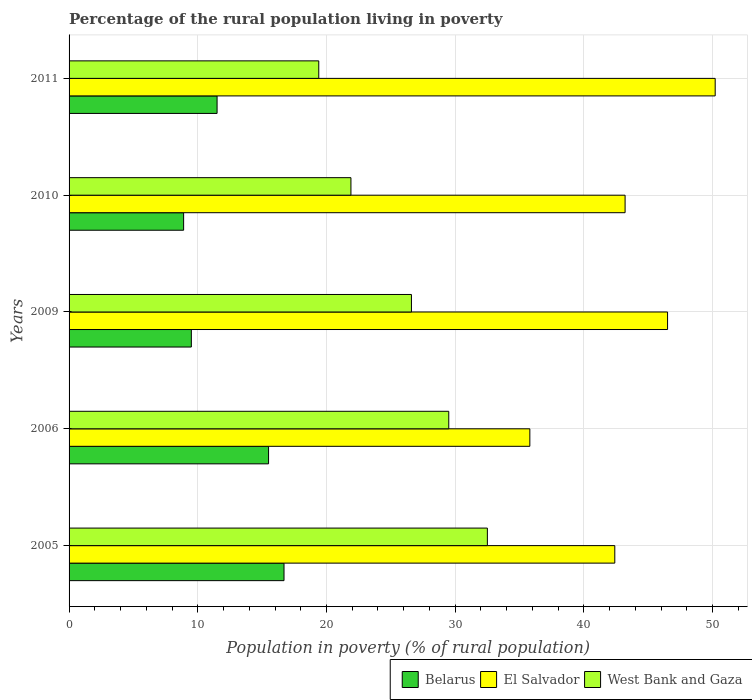How many groups of bars are there?
Your answer should be compact. 5. Are the number of bars on each tick of the Y-axis equal?
Offer a very short reply. Yes. How many bars are there on the 5th tick from the top?
Provide a succinct answer. 3. What is the label of the 4th group of bars from the top?
Make the answer very short. 2006. In how many cases, is the number of bars for a given year not equal to the number of legend labels?
Offer a very short reply. 0. Across all years, what is the maximum percentage of the rural population living in poverty in West Bank and Gaza?
Make the answer very short. 32.5. In which year was the percentage of the rural population living in poverty in West Bank and Gaza maximum?
Your answer should be very brief. 2005. In which year was the percentage of the rural population living in poverty in Belarus minimum?
Offer a terse response. 2010. What is the total percentage of the rural population living in poverty in West Bank and Gaza in the graph?
Your answer should be compact. 129.9. What is the difference between the percentage of the rural population living in poverty in West Bank and Gaza in 2006 and that in 2009?
Provide a short and direct response. 2.9. What is the average percentage of the rural population living in poverty in West Bank and Gaza per year?
Your answer should be compact. 25.98. In the year 2005, what is the difference between the percentage of the rural population living in poverty in El Salvador and percentage of the rural population living in poverty in Belarus?
Provide a short and direct response. 25.7. In how many years, is the percentage of the rural population living in poverty in West Bank and Gaza greater than 6 %?
Offer a very short reply. 5. What is the ratio of the percentage of the rural population living in poverty in Belarus in 2005 to that in 2009?
Your answer should be compact. 1.76. Is the percentage of the rural population living in poverty in El Salvador in 2009 less than that in 2011?
Keep it short and to the point. Yes. Is the difference between the percentage of the rural population living in poverty in El Salvador in 2006 and 2010 greater than the difference between the percentage of the rural population living in poverty in Belarus in 2006 and 2010?
Your response must be concise. No. What is the difference between the highest and the second highest percentage of the rural population living in poverty in El Salvador?
Keep it short and to the point. 3.7. What is the difference between the highest and the lowest percentage of the rural population living in poverty in Belarus?
Give a very brief answer. 7.8. In how many years, is the percentage of the rural population living in poverty in West Bank and Gaza greater than the average percentage of the rural population living in poverty in West Bank and Gaza taken over all years?
Keep it short and to the point. 3. What does the 3rd bar from the top in 2010 represents?
Your answer should be compact. Belarus. What does the 2nd bar from the bottom in 2011 represents?
Your answer should be very brief. El Salvador. Are all the bars in the graph horizontal?
Provide a short and direct response. Yes. Are the values on the major ticks of X-axis written in scientific E-notation?
Keep it short and to the point. No. Does the graph contain any zero values?
Ensure brevity in your answer.  No. Does the graph contain grids?
Provide a short and direct response. Yes. Where does the legend appear in the graph?
Offer a very short reply. Bottom right. What is the title of the graph?
Your answer should be compact. Percentage of the rural population living in poverty. What is the label or title of the X-axis?
Keep it short and to the point. Population in poverty (% of rural population). What is the label or title of the Y-axis?
Offer a terse response. Years. What is the Population in poverty (% of rural population) in Belarus in 2005?
Provide a succinct answer. 16.7. What is the Population in poverty (% of rural population) in El Salvador in 2005?
Give a very brief answer. 42.4. What is the Population in poverty (% of rural population) in West Bank and Gaza in 2005?
Provide a short and direct response. 32.5. What is the Population in poverty (% of rural population) of Belarus in 2006?
Offer a very short reply. 15.5. What is the Population in poverty (% of rural population) in El Salvador in 2006?
Keep it short and to the point. 35.8. What is the Population in poverty (% of rural population) of West Bank and Gaza in 2006?
Provide a succinct answer. 29.5. What is the Population in poverty (% of rural population) in Belarus in 2009?
Provide a succinct answer. 9.5. What is the Population in poverty (% of rural population) of El Salvador in 2009?
Give a very brief answer. 46.5. What is the Population in poverty (% of rural population) in West Bank and Gaza in 2009?
Your answer should be very brief. 26.6. What is the Population in poverty (% of rural population) of Belarus in 2010?
Offer a very short reply. 8.9. What is the Population in poverty (% of rural population) of El Salvador in 2010?
Ensure brevity in your answer.  43.2. What is the Population in poverty (% of rural population) of West Bank and Gaza in 2010?
Offer a very short reply. 21.9. What is the Population in poverty (% of rural population) in El Salvador in 2011?
Provide a short and direct response. 50.2. Across all years, what is the maximum Population in poverty (% of rural population) of Belarus?
Give a very brief answer. 16.7. Across all years, what is the maximum Population in poverty (% of rural population) of El Salvador?
Ensure brevity in your answer.  50.2. Across all years, what is the maximum Population in poverty (% of rural population) in West Bank and Gaza?
Your answer should be very brief. 32.5. Across all years, what is the minimum Population in poverty (% of rural population) in El Salvador?
Your answer should be very brief. 35.8. What is the total Population in poverty (% of rural population) in Belarus in the graph?
Ensure brevity in your answer.  62.1. What is the total Population in poverty (% of rural population) in El Salvador in the graph?
Offer a very short reply. 218.1. What is the total Population in poverty (% of rural population) of West Bank and Gaza in the graph?
Give a very brief answer. 129.9. What is the difference between the Population in poverty (% of rural population) of Belarus in 2005 and that in 2006?
Your response must be concise. 1.2. What is the difference between the Population in poverty (% of rural population) in El Salvador in 2005 and that in 2006?
Ensure brevity in your answer.  6.6. What is the difference between the Population in poverty (% of rural population) of West Bank and Gaza in 2005 and that in 2006?
Offer a very short reply. 3. What is the difference between the Population in poverty (% of rural population) in Belarus in 2005 and that in 2009?
Your answer should be compact. 7.2. What is the difference between the Population in poverty (% of rural population) of El Salvador in 2005 and that in 2010?
Offer a terse response. -0.8. What is the difference between the Population in poverty (% of rural population) of West Bank and Gaza in 2005 and that in 2010?
Your response must be concise. 10.6. What is the difference between the Population in poverty (% of rural population) in El Salvador in 2005 and that in 2011?
Keep it short and to the point. -7.8. What is the difference between the Population in poverty (% of rural population) of West Bank and Gaza in 2005 and that in 2011?
Ensure brevity in your answer.  13.1. What is the difference between the Population in poverty (% of rural population) of Belarus in 2006 and that in 2009?
Provide a short and direct response. 6. What is the difference between the Population in poverty (% of rural population) in El Salvador in 2006 and that in 2009?
Provide a succinct answer. -10.7. What is the difference between the Population in poverty (% of rural population) of El Salvador in 2006 and that in 2011?
Keep it short and to the point. -14.4. What is the difference between the Population in poverty (% of rural population) of Belarus in 2009 and that in 2011?
Provide a short and direct response. -2. What is the difference between the Population in poverty (% of rural population) of El Salvador in 2009 and that in 2011?
Keep it short and to the point. -3.7. What is the difference between the Population in poverty (% of rural population) of Belarus in 2010 and that in 2011?
Offer a terse response. -2.6. What is the difference between the Population in poverty (% of rural population) of West Bank and Gaza in 2010 and that in 2011?
Offer a very short reply. 2.5. What is the difference between the Population in poverty (% of rural population) of Belarus in 2005 and the Population in poverty (% of rural population) of El Salvador in 2006?
Keep it short and to the point. -19.1. What is the difference between the Population in poverty (% of rural population) in Belarus in 2005 and the Population in poverty (% of rural population) in West Bank and Gaza in 2006?
Your answer should be compact. -12.8. What is the difference between the Population in poverty (% of rural population) in El Salvador in 2005 and the Population in poverty (% of rural population) in West Bank and Gaza in 2006?
Offer a terse response. 12.9. What is the difference between the Population in poverty (% of rural population) of Belarus in 2005 and the Population in poverty (% of rural population) of El Salvador in 2009?
Your answer should be compact. -29.8. What is the difference between the Population in poverty (% of rural population) in Belarus in 2005 and the Population in poverty (% of rural population) in West Bank and Gaza in 2009?
Make the answer very short. -9.9. What is the difference between the Population in poverty (% of rural population) of Belarus in 2005 and the Population in poverty (% of rural population) of El Salvador in 2010?
Your answer should be very brief. -26.5. What is the difference between the Population in poverty (% of rural population) in El Salvador in 2005 and the Population in poverty (% of rural population) in West Bank and Gaza in 2010?
Provide a succinct answer. 20.5. What is the difference between the Population in poverty (% of rural population) in Belarus in 2005 and the Population in poverty (% of rural population) in El Salvador in 2011?
Your response must be concise. -33.5. What is the difference between the Population in poverty (% of rural population) in Belarus in 2005 and the Population in poverty (% of rural population) in West Bank and Gaza in 2011?
Make the answer very short. -2.7. What is the difference between the Population in poverty (% of rural population) of El Salvador in 2005 and the Population in poverty (% of rural population) of West Bank and Gaza in 2011?
Provide a succinct answer. 23. What is the difference between the Population in poverty (% of rural population) of Belarus in 2006 and the Population in poverty (% of rural population) of El Salvador in 2009?
Your response must be concise. -31. What is the difference between the Population in poverty (% of rural population) of El Salvador in 2006 and the Population in poverty (% of rural population) of West Bank and Gaza in 2009?
Your response must be concise. 9.2. What is the difference between the Population in poverty (% of rural population) of Belarus in 2006 and the Population in poverty (% of rural population) of El Salvador in 2010?
Your response must be concise. -27.7. What is the difference between the Population in poverty (% of rural population) of Belarus in 2006 and the Population in poverty (% of rural population) of El Salvador in 2011?
Your response must be concise. -34.7. What is the difference between the Population in poverty (% of rural population) of El Salvador in 2006 and the Population in poverty (% of rural population) of West Bank and Gaza in 2011?
Provide a succinct answer. 16.4. What is the difference between the Population in poverty (% of rural population) in Belarus in 2009 and the Population in poverty (% of rural population) in El Salvador in 2010?
Ensure brevity in your answer.  -33.7. What is the difference between the Population in poverty (% of rural population) of Belarus in 2009 and the Population in poverty (% of rural population) of West Bank and Gaza in 2010?
Keep it short and to the point. -12.4. What is the difference between the Population in poverty (% of rural population) in El Salvador in 2009 and the Population in poverty (% of rural population) in West Bank and Gaza in 2010?
Your response must be concise. 24.6. What is the difference between the Population in poverty (% of rural population) of Belarus in 2009 and the Population in poverty (% of rural population) of El Salvador in 2011?
Your answer should be very brief. -40.7. What is the difference between the Population in poverty (% of rural population) of El Salvador in 2009 and the Population in poverty (% of rural population) of West Bank and Gaza in 2011?
Your answer should be compact. 27.1. What is the difference between the Population in poverty (% of rural population) of Belarus in 2010 and the Population in poverty (% of rural population) of El Salvador in 2011?
Offer a terse response. -41.3. What is the difference between the Population in poverty (% of rural population) of Belarus in 2010 and the Population in poverty (% of rural population) of West Bank and Gaza in 2011?
Your response must be concise. -10.5. What is the difference between the Population in poverty (% of rural population) in El Salvador in 2010 and the Population in poverty (% of rural population) in West Bank and Gaza in 2011?
Ensure brevity in your answer.  23.8. What is the average Population in poverty (% of rural population) of Belarus per year?
Offer a very short reply. 12.42. What is the average Population in poverty (% of rural population) of El Salvador per year?
Make the answer very short. 43.62. What is the average Population in poverty (% of rural population) in West Bank and Gaza per year?
Your answer should be very brief. 25.98. In the year 2005, what is the difference between the Population in poverty (% of rural population) in Belarus and Population in poverty (% of rural population) in El Salvador?
Provide a short and direct response. -25.7. In the year 2005, what is the difference between the Population in poverty (% of rural population) of Belarus and Population in poverty (% of rural population) of West Bank and Gaza?
Your response must be concise. -15.8. In the year 2005, what is the difference between the Population in poverty (% of rural population) in El Salvador and Population in poverty (% of rural population) in West Bank and Gaza?
Keep it short and to the point. 9.9. In the year 2006, what is the difference between the Population in poverty (% of rural population) in Belarus and Population in poverty (% of rural population) in El Salvador?
Offer a very short reply. -20.3. In the year 2009, what is the difference between the Population in poverty (% of rural population) of Belarus and Population in poverty (% of rural population) of El Salvador?
Ensure brevity in your answer.  -37. In the year 2009, what is the difference between the Population in poverty (% of rural population) in Belarus and Population in poverty (% of rural population) in West Bank and Gaza?
Your response must be concise. -17.1. In the year 2010, what is the difference between the Population in poverty (% of rural population) in Belarus and Population in poverty (% of rural population) in El Salvador?
Your answer should be very brief. -34.3. In the year 2010, what is the difference between the Population in poverty (% of rural population) of Belarus and Population in poverty (% of rural population) of West Bank and Gaza?
Offer a terse response. -13. In the year 2010, what is the difference between the Population in poverty (% of rural population) of El Salvador and Population in poverty (% of rural population) of West Bank and Gaza?
Offer a terse response. 21.3. In the year 2011, what is the difference between the Population in poverty (% of rural population) in Belarus and Population in poverty (% of rural population) in El Salvador?
Offer a terse response. -38.7. In the year 2011, what is the difference between the Population in poverty (% of rural population) in El Salvador and Population in poverty (% of rural population) in West Bank and Gaza?
Offer a terse response. 30.8. What is the ratio of the Population in poverty (% of rural population) of Belarus in 2005 to that in 2006?
Provide a succinct answer. 1.08. What is the ratio of the Population in poverty (% of rural population) of El Salvador in 2005 to that in 2006?
Your answer should be very brief. 1.18. What is the ratio of the Population in poverty (% of rural population) in West Bank and Gaza in 2005 to that in 2006?
Give a very brief answer. 1.1. What is the ratio of the Population in poverty (% of rural population) in Belarus in 2005 to that in 2009?
Provide a short and direct response. 1.76. What is the ratio of the Population in poverty (% of rural population) in El Salvador in 2005 to that in 2009?
Your answer should be very brief. 0.91. What is the ratio of the Population in poverty (% of rural population) of West Bank and Gaza in 2005 to that in 2009?
Give a very brief answer. 1.22. What is the ratio of the Population in poverty (% of rural population) of Belarus in 2005 to that in 2010?
Make the answer very short. 1.88. What is the ratio of the Population in poverty (% of rural population) of El Salvador in 2005 to that in 2010?
Your response must be concise. 0.98. What is the ratio of the Population in poverty (% of rural population) of West Bank and Gaza in 2005 to that in 2010?
Make the answer very short. 1.48. What is the ratio of the Population in poverty (% of rural population) in Belarus in 2005 to that in 2011?
Your answer should be very brief. 1.45. What is the ratio of the Population in poverty (% of rural population) in El Salvador in 2005 to that in 2011?
Offer a very short reply. 0.84. What is the ratio of the Population in poverty (% of rural population) of West Bank and Gaza in 2005 to that in 2011?
Your response must be concise. 1.68. What is the ratio of the Population in poverty (% of rural population) of Belarus in 2006 to that in 2009?
Keep it short and to the point. 1.63. What is the ratio of the Population in poverty (% of rural population) of El Salvador in 2006 to that in 2009?
Provide a short and direct response. 0.77. What is the ratio of the Population in poverty (% of rural population) of West Bank and Gaza in 2006 to that in 2009?
Your response must be concise. 1.11. What is the ratio of the Population in poverty (% of rural population) of Belarus in 2006 to that in 2010?
Offer a terse response. 1.74. What is the ratio of the Population in poverty (% of rural population) in El Salvador in 2006 to that in 2010?
Keep it short and to the point. 0.83. What is the ratio of the Population in poverty (% of rural population) of West Bank and Gaza in 2006 to that in 2010?
Make the answer very short. 1.35. What is the ratio of the Population in poverty (% of rural population) in Belarus in 2006 to that in 2011?
Provide a succinct answer. 1.35. What is the ratio of the Population in poverty (% of rural population) of El Salvador in 2006 to that in 2011?
Give a very brief answer. 0.71. What is the ratio of the Population in poverty (% of rural population) in West Bank and Gaza in 2006 to that in 2011?
Offer a very short reply. 1.52. What is the ratio of the Population in poverty (% of rural population) in Belarus in 2009 to that in 2010?
Your response must be concise. 1.07. What is the ratio of the Population in poverty (% of rural population) in El Salvador in 2009 to that in 2010?
Keep it short and to the point. 1.08. What is the ratio of the Population in poverty (% of rural population) of West Bank and Gaza in 2009 to that in 2010?
Provide a short and direct response. 1.21. What is the ratio of the Population in poverty (% of rural population) in Belarus in 2009 to that in 2011?
Give a very brief answer. 0.83. What is the ratio of the Population in poverty (% of rural population) in El Salvador in 2009 to that in 2011?
Provide a succinct answer. 0.93. What is the ratio of the Population in poverty (% of rural population) of West Bank and Gaza in 2009 to that in 2011?
Give a very brief answer. 1.37. What is the ratio of the Population in poverty (% of rural population) of Belarus in 2010 to that in 2011?
Provide a succinct answer. 0.77. What is the ratio of the Population in poverty (% of rural population) of El Salvador in 2010 to that in 2011?
Your answer should be compact. 0.86. What is the ratio of the Population in poverty (% of rural population) of West Bank and Gaza in 2010 to that in 2011?
Make the answer very short. 1.13. What is the difference between the highest and the lowest Population in poverty (% of rural population) of Belarus?
Offer a very short reply. 7.8. 